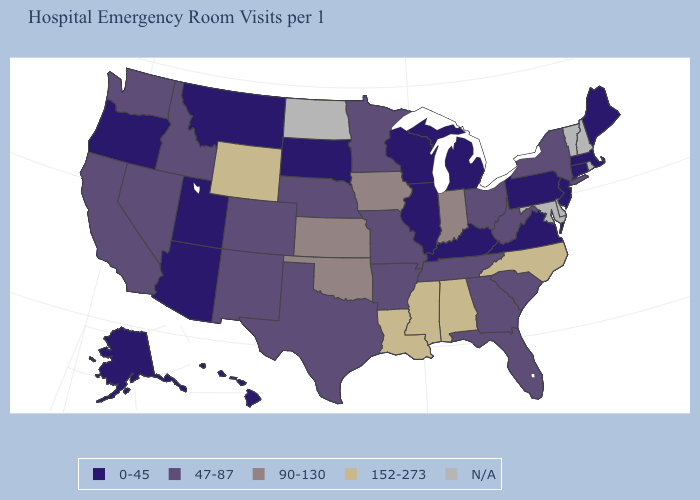What is the highest value in the Northeast ?
Be succinct. 47-87. Does Illinois have the lowest value in the MidWest?
Give a very brief answer. Yes. What is the highest value in the West ?
Concise answer only. 152-273. Among the states that border Georgia , which have the lowest value?
Keep it brief. Florida, South Carolina, Tennessee. What is the highest value in the USA?
Concise answer only. 152-273. Is the legend a continuous bar?
Be succinct. No. Among the states that border Iowa , does Wisconsin have the lowest value?
Quick response, please. Yes. Does Kansas have the highest value in the MidWest?
Concise answer only. Yes. Among the states that border Washington , which have the lowest value?
Give a very brief answer. Oregon. What is the highest value in the USA?
Be succinct. 152-273. Does the map have missing data?
Concise answer only. Yes. What is the lowest value in the West?
Be succinct. 0-45. Does Oregon have the lowest value in the West?
Short answer required. Yes. Among the states that border Iowa , which have the lowest value?
Short answer required. Illinois, South Dakota, Wisconsin. 